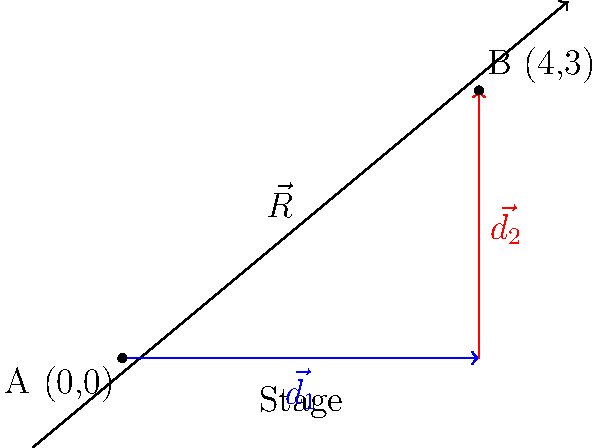As part of your latest performance, you need to move diagonally across the stage. You first move 4 meters to the right, then 3 meters upstage. Calculate the magnitude of the resultant displacement vector $\vec{R}$ from your initial position A(0,0) to your final position B(4,3). To solve this problem, we'll use the following steps:

1) The movement can be broken down into two displacement vectors:
   $\vec{d_1} = 4\hat{i}$ (4 meters right)
   $\vec{d_2} = 3\hat{j}$ (3 meters up)

2) The resultant displacement vector $\vec{R}$ is the sum of these two vectors:
   $\vec{R} = \vec{d_1} + \vec{d_2} = 4\hat{i} + 3\hat{j}$

3) To find the magnitude of $\vec{R}$, we use the Pythagorean theorem:
   $|\vec{R}| = \sqrt{(4)^2 + (3)^2}$

4) Simplify:
   $|\vec{R}| = \sqrt{16 + 9} = \sqrt{25} = 5$

Therefore, the magnitude of the resultant displacement vector is 5 meters.
Answer: 5 meters 